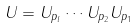Convert formula to latex. <formula><loc_0><loc_0><loc_500><loc_500>U = U _ { p _ { l } } \cdots U _ { p _ { 2 } } U _ { p _ { 1 } }</formula> 